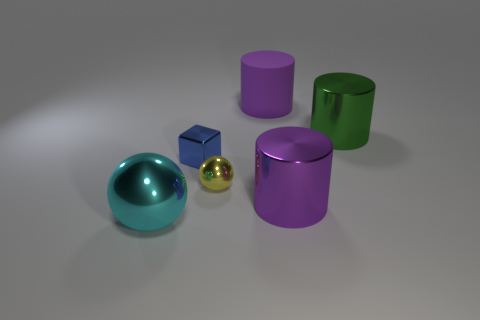Add 2 green cylinders. How many objects exist? 8 Subtract all blocks. How many objects are left? 5 Subtract all big green metal objects. Subtract all green metallic cylinders. How many objects are left? 4 Add 6 green objects. How many green objects are left? 7 Add 5 small blue things. How many small blue things exist? 6 Subtract 1 cyan balls. How many objects are left? 5 